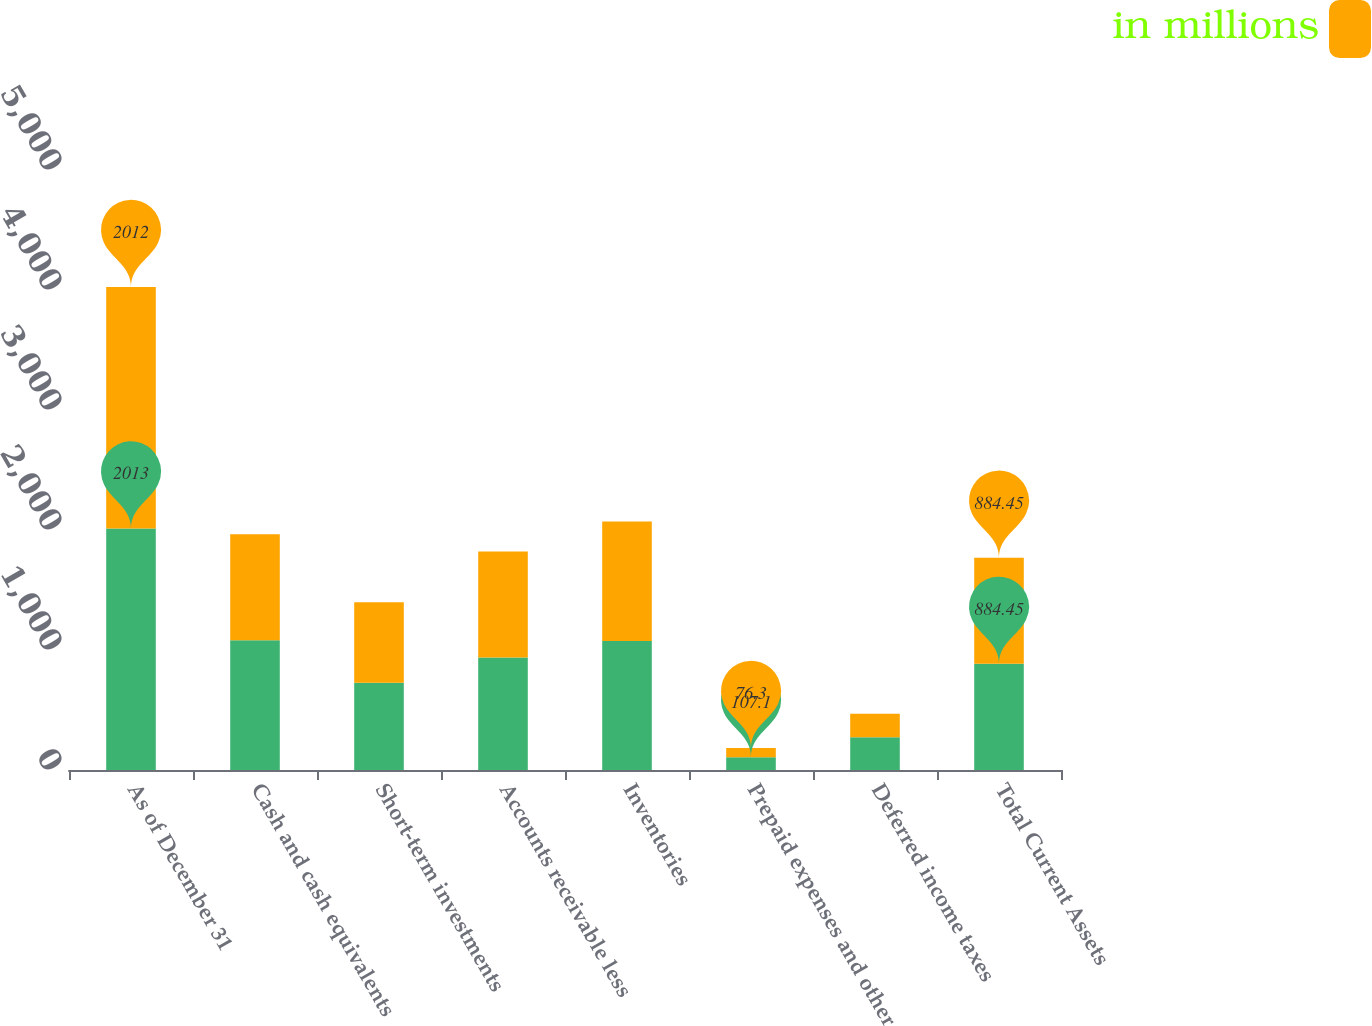<chart> <loc_0><loc_0><loc_500><loc_500><stacked_bar_chart><ecel><fcel>As of December 31<fcel>Cash and cash equivalents<fcel>Short-term investments<fcel>Accounts receivable less<fcel>Inventories<fcel>Prepaid expenses and other<fcel>Deferred income taxes<fcel>Total Current Assets<nl><fcel>nan<fcel>2013<fcel>1080.6<fcel>727<fcel>936.6<fcel>1074.5<fcel>107.1<fcel>271.9<fcel>884.45<nl><fcel>in millions<fcel>2012<fcel>884.3<fcel>671.6<fcel>884.6<fcel>995.3<fcel>76.3<fcel>196.6<fcel>884.45<nl></chart> 